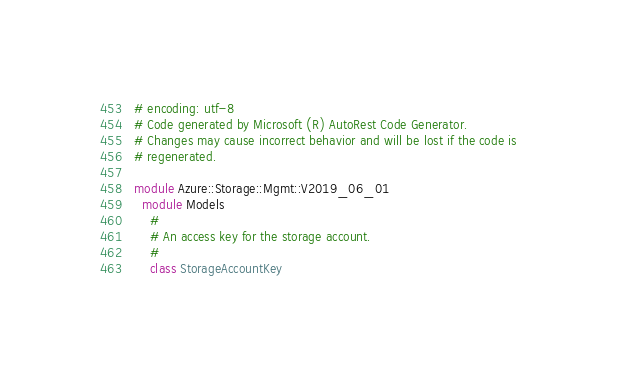<code> <loc_0><loc_0><loc_500><loc_500><_Ruby_># encoding: utf-8
# Code generated by Microsoft (R) AutoRest Code Generator.
# Changes may cause incorrect behavior and will be lost if the code is
# regenerated.

module Azure::Storage::Mgmt::V2019_06_01
  module Models
    #
    # An access key for the storage account.
    #
    class StorageAccountKey
</code> 